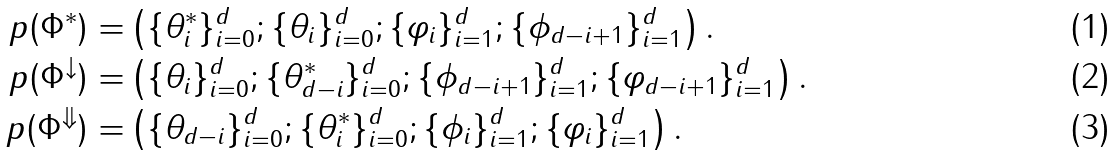Convert formula to latex. <formula><loc_0><loc_0><loc_500><loc_500>p ( \Phi ^ { * } ) = & \left ( \{ \theta _ { i } ^ { * } \} _ { i = 0 } ^ { d } ; \{ \theta _ { i } \} _ { i = 0 } ^ { d } ; \{ \varphi _ { i } \} _ { i = 1 } ^ { d } ; \{ \phi _ { d - i + 1 } \} _ { i = 1 } ^ { d } \right ) . \\ p ( \Phi ^ { \downarrow } ) = & \left ( \{ \theta _ { i } \} _ { i = 0 } ^ { d } ; \{ \theta _ { d - i } ^ { * } \} _ { i = 0 } ^ { d } ; \{ \phi _ { d - i + 1 } \} _ { i = 1 } ^ { d } ; \{ \varphi _ { d - i + 1 } \} _ { i = 1 } ^ { d } \right ) . \\ p ( \Phi ^ { \Downarrow } ) = & \left ( \{ \theta _ { d - i } \} _ { i = 0 } ^ { d } ; \{ \theta _ { i } ^ { * } \} _ { i = 0 } ^ { d } ; \{ \phi _ { i } \} _ { i = 1 } ^ { d } ; \{ \varphi _ { i } \} _ { i = 1 } ^ { d } \right ) .</formula> 